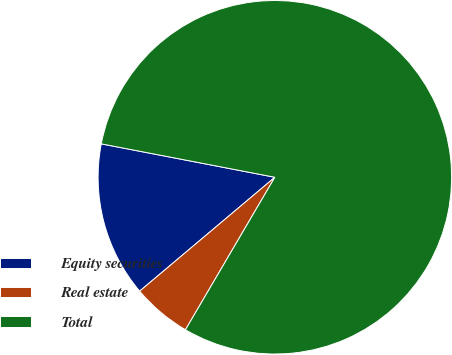<chart> <loc_0><loc_0><loc_500><loc_500><pie_chart><fcel>Equity securities<fcel>Real estate<fcel>Total<nl><fcel>14.17%<fcel>5.42%<fcel>80.42%<nl></chart> 